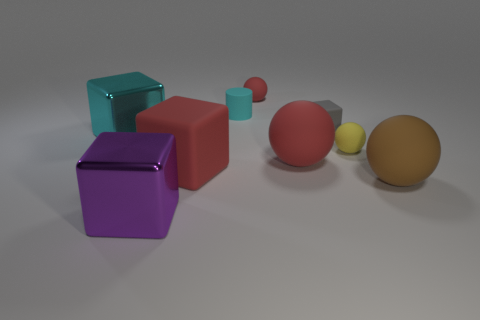There is a small rubber object that is the same color as the large matte block; what shape is it?
Make the answer very short. Sphere. Are there any big brown spheres that have the same material as the tiny red object?
Give a very brief answer. Yes. How many matte things are either red things or purple cylinders?
Make the answer very short. 3. The cyan matte object behind the big rubber object that is in front of the large red block is what shape?
Ensure brevity in your answer.  Cylinder. Are there fewer tiny yellow objects on the right side of the big cyan shiny thing than cyan objects?
Your answer should be very brief. Yes. What is the shape of the purple metal object?
Your answer should be very brief. Cube. What size is the rubber block that is in front of the tiny yellow sphere?
Provide a succinct answer. Large. The cylinder that is the same size as the yellow object is what color?
Provide a succinct answer. Cyan. Are there any metallic cubes that have the same color as the cylinder?
Keep it short and to the point. Yes. Are there fewer balls on the left side of the tiny matte cube than small gray objects that are in front of the large cyan shiny thing?
Provide a short and direct response. No. 